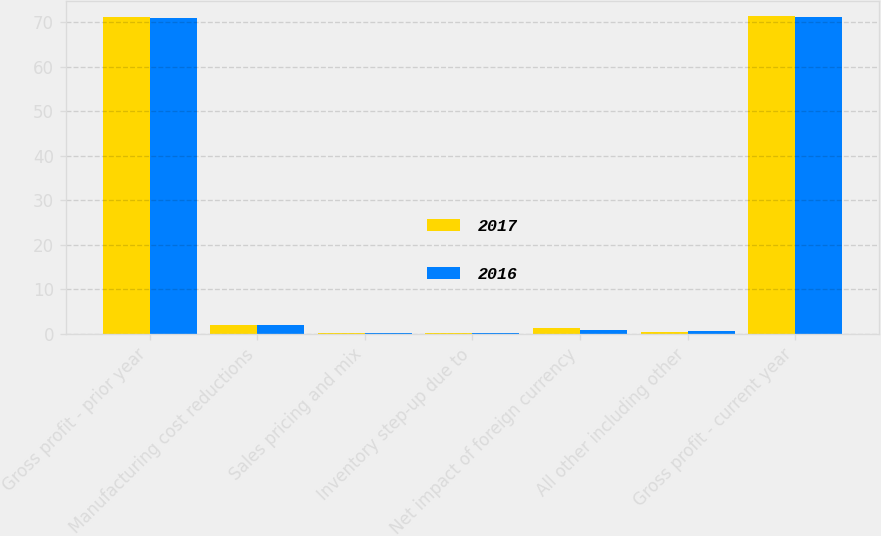Convert chart to OTSL. <chart><loc_0><loc_0><loc_500><loc_500><stacked_bar_chart><ecel><fcel>Gross profit - prior year<fcel>Manufacturing cost reductions<fcel>Sales pricing and mix<fcel>Inventory step-up due to<fcel>Net impact of foreign currency<fcel>All other including other<fcel>Gross profit - current year<nl><fcel>2017<fcel>71.1<fcel>1.9<fcel>0.1<fcel>0.2<fcel>1.3<fcel>0.3<fcel>71.3<nl><fcel>2016<fcel>70.9<fcel>2<fcel>0.1<fcel>0.2<fcel>0.9<fcel>0.6<fcel>71.1<nl></chart> 